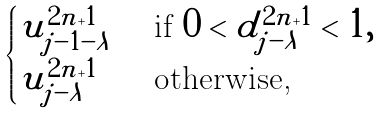<formula> <loc_0><loc_0><loc_500><loc_500>\begin{cases} u _ { j - 1 - \lambda } ^ { 2 n + 1 } & \text { if } 0 < d _ { j - \lambda } ^ { 2 n + 1 } < 1 , \\ u _ { j - \lambda } ^ { 2 n + 1 } & \text { otherwise, } \\ \end{cases}</formula> 